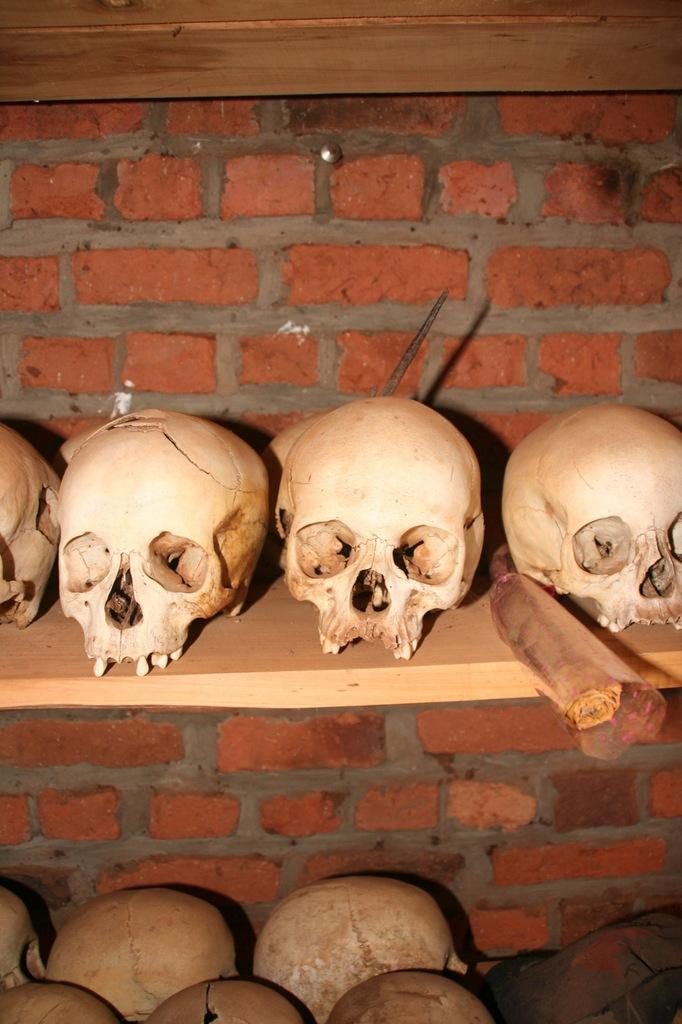What objects are present in the image? There are skulls in the image. Where are the skulls located? The skulls are on a wooden shelf. What type of wall is visible in the image? There is a brick wall in the image. Can you describe the color of the brick wall? The brick wall has brown and ash colors. Can you tell me how many donkeys are standing next to the brick wall in the image? There are no donkeys present in the image; it only features skulls on a wooden shelf and a brick wall. 